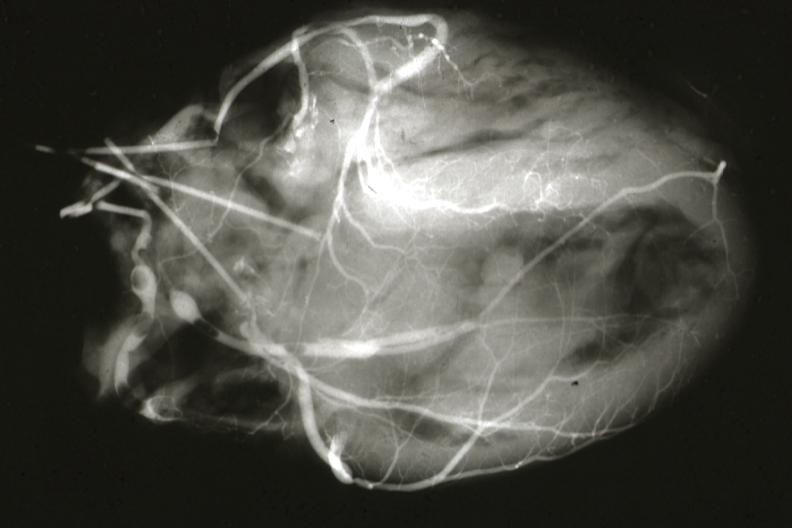does acid show postmortangiogram of coronary arteries?
Answer the question using a single word or phrase. No 